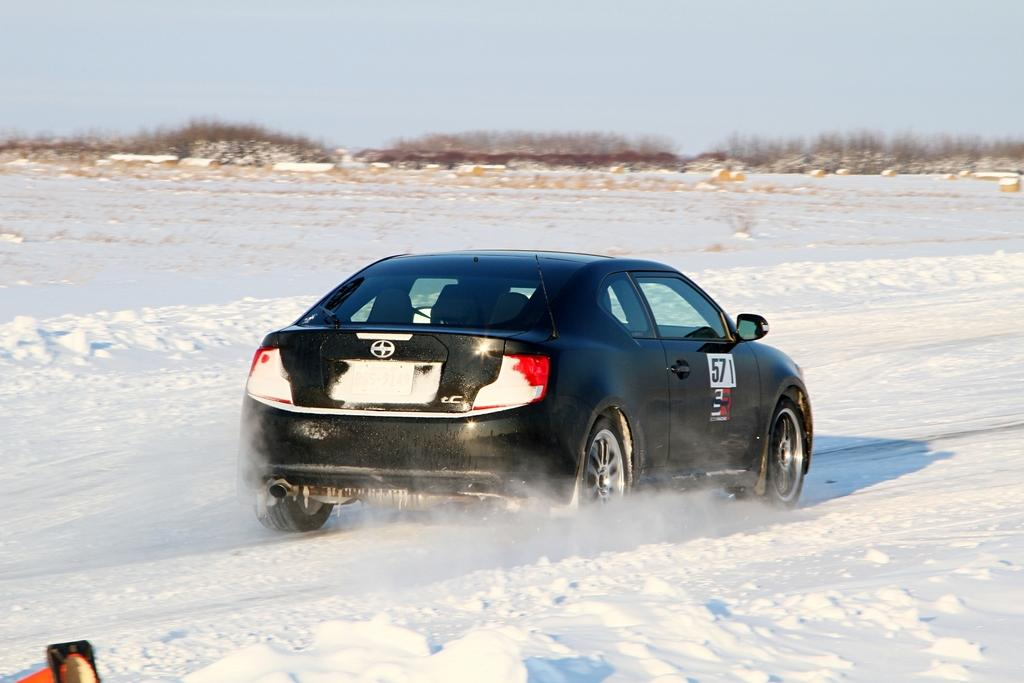What is the main feature in the center of the image? There is snow in the center of the image. What can be seen in the foreground of the image? There is a car in the foreground of the image. What type of vegetation is visible in the background of the image? There are shrubs and grass in the background of the image. How would you describe the weather in the image? The sky is sunny in the image, suggesting a clear and bright day. What type of lunch is being served in the image? There is no lunch or any food visible in the image; it primarily features snow, a car, and vegetation. 